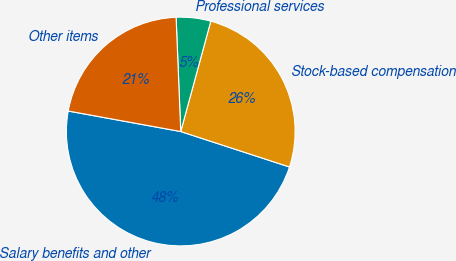Convert chart. <chart><loc_0><loc_0><loc_500><loc_500><pie_chart><fcel>Salary benefits and other<fcel>Stock-based compensation<fcel>Professional services<fcel>Other items<nl><fcel>47.85%<fcel>25.78%<fcel>4.88%<fcel>21.48%<nl></chart> 